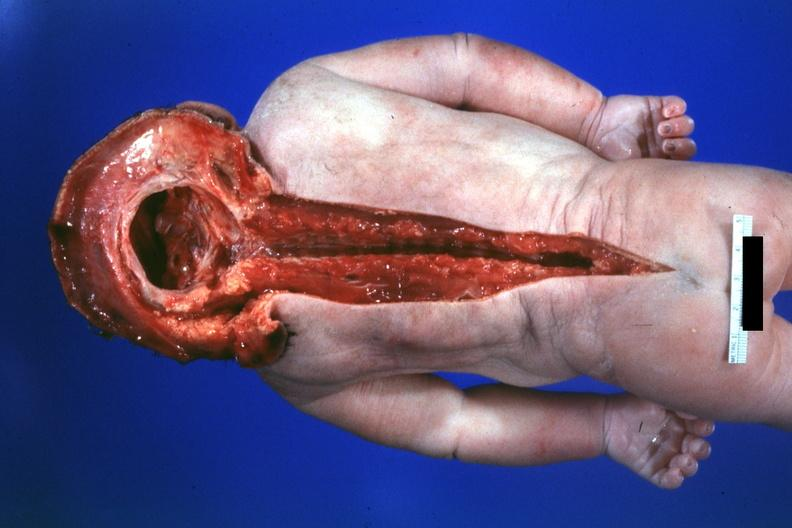what is present?
Answer the question using a single word or phrase. Brain 